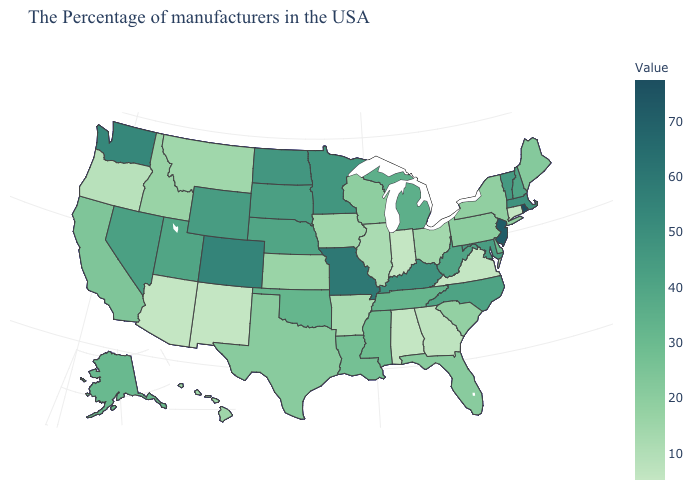Among the states that border Delaware , which have the highest value?
Quick response, please. New Jersey. Does Rhode Island have the highest value in the USA?
Answer briefly. Yes. Among the states that border Alabama , does Mississippi have the highest value?
Write a very short answer. No. Is the legend a continuous bar?
Give a very brief answer. Yes. 